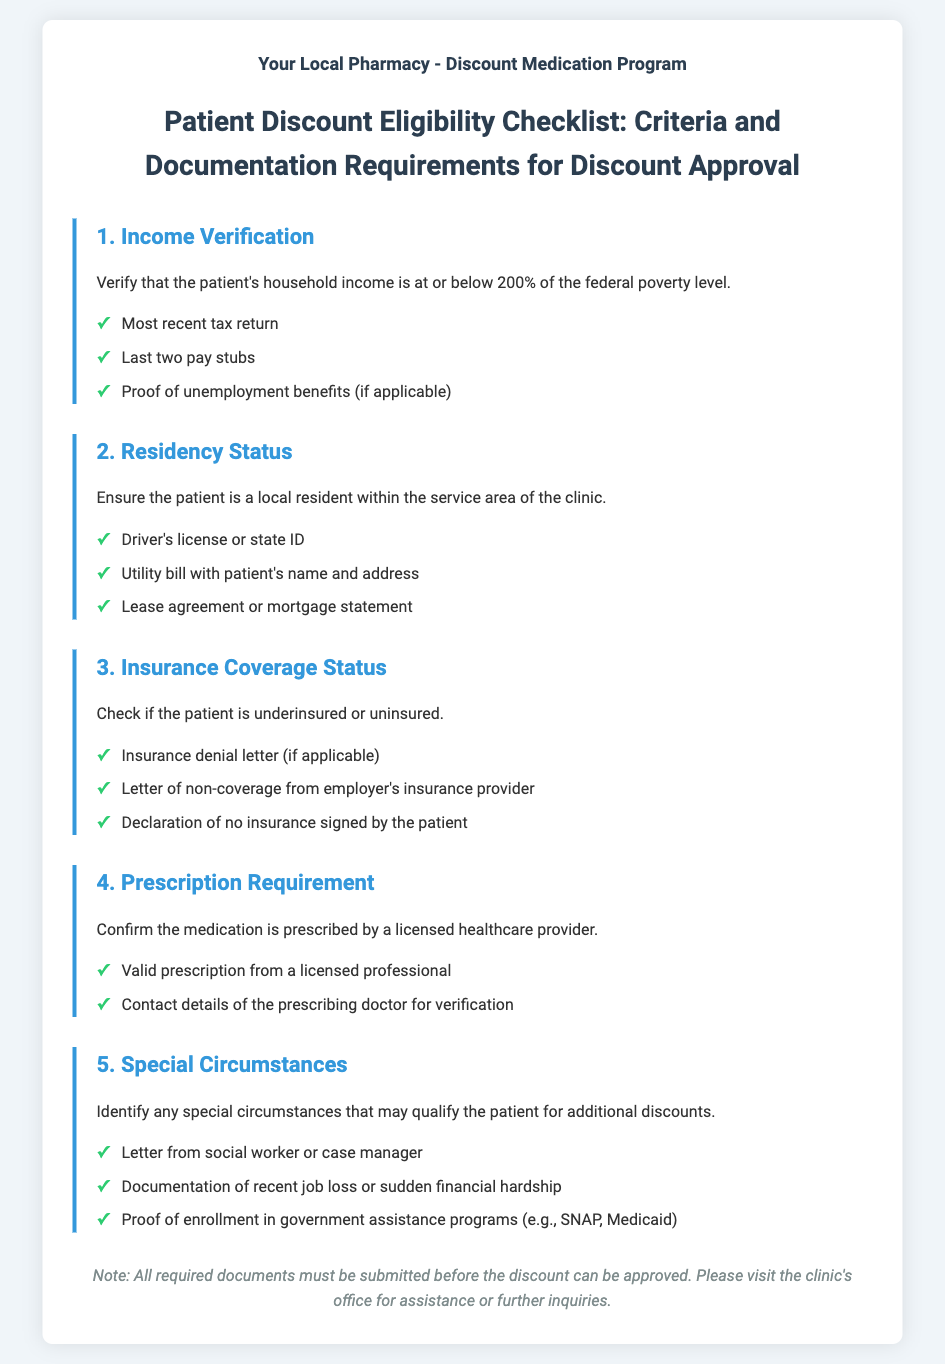What is the maximum household income to qualify? The document states that the patient's household income must be at or below 200% of the federal poverty level.
Answer: 200% What type of document is required for residency verification? The checklist lists specific documents needed to verify residency status, among them a utility bill.
Answer: Utility bill What is one way to prove insurance coverage status? The document mentions that an insurance denial letter can be used to check insurance coverage status.
Answer: Insurance denial letter What must the prescription be from? The document specifies that a valid prescription must come from a licensed healthcare provider.
Answer: Licensed healthcare provider What should be provided for special circumstances? The checklist indicates various types of documentation, including a letter from a social worker, to qualify for additional discounts.
Answer: Letter from social worker How many pay stubs are required for income verification? The document specifies that the last two pay stubs are necessary for income verification.
Answer: Two pay stubs What type of statement can indicate job loss? The document includes documentation of recent job loss or sudden financial hardship as a special circumstance.
Answer: Documentation of recent job loss What is the role of a case manager in this checklist? A letter from a case manager can serve as documentation for special circumstances qualifying the patient for additional discounts.
Answer: Letter from case manager 